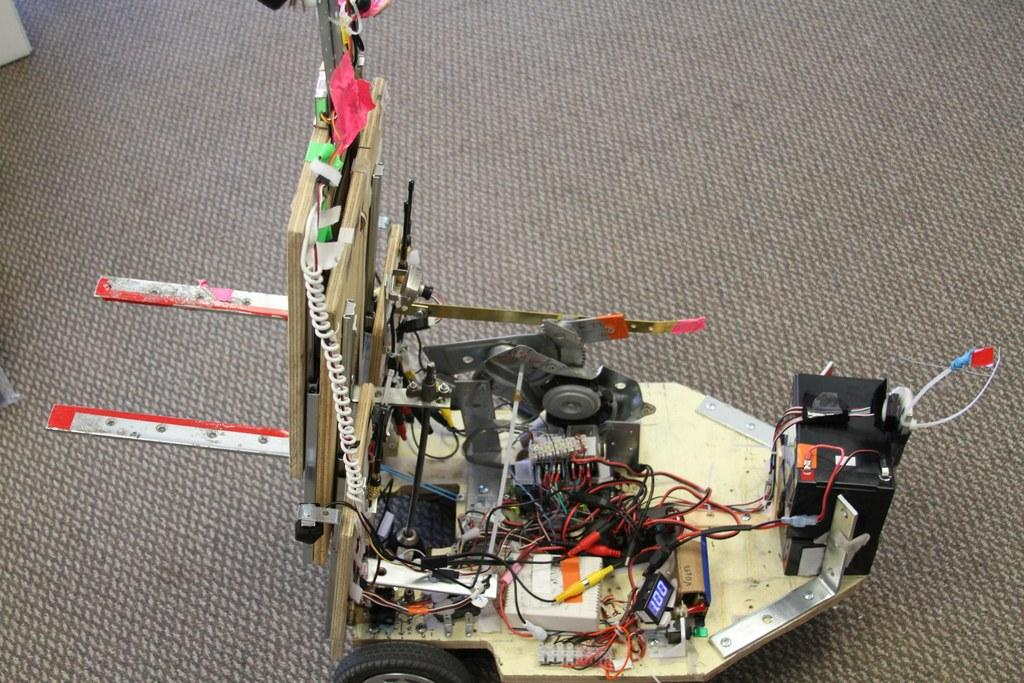What is the main subject of the image? There is a gadget in the image. Where is the plantation located in the image? There is no plantation present in the image; it only features a gadget. What type of cart is used to transport the basket in the image? There is no basket or cart present in the image; only a gadget is visible. 